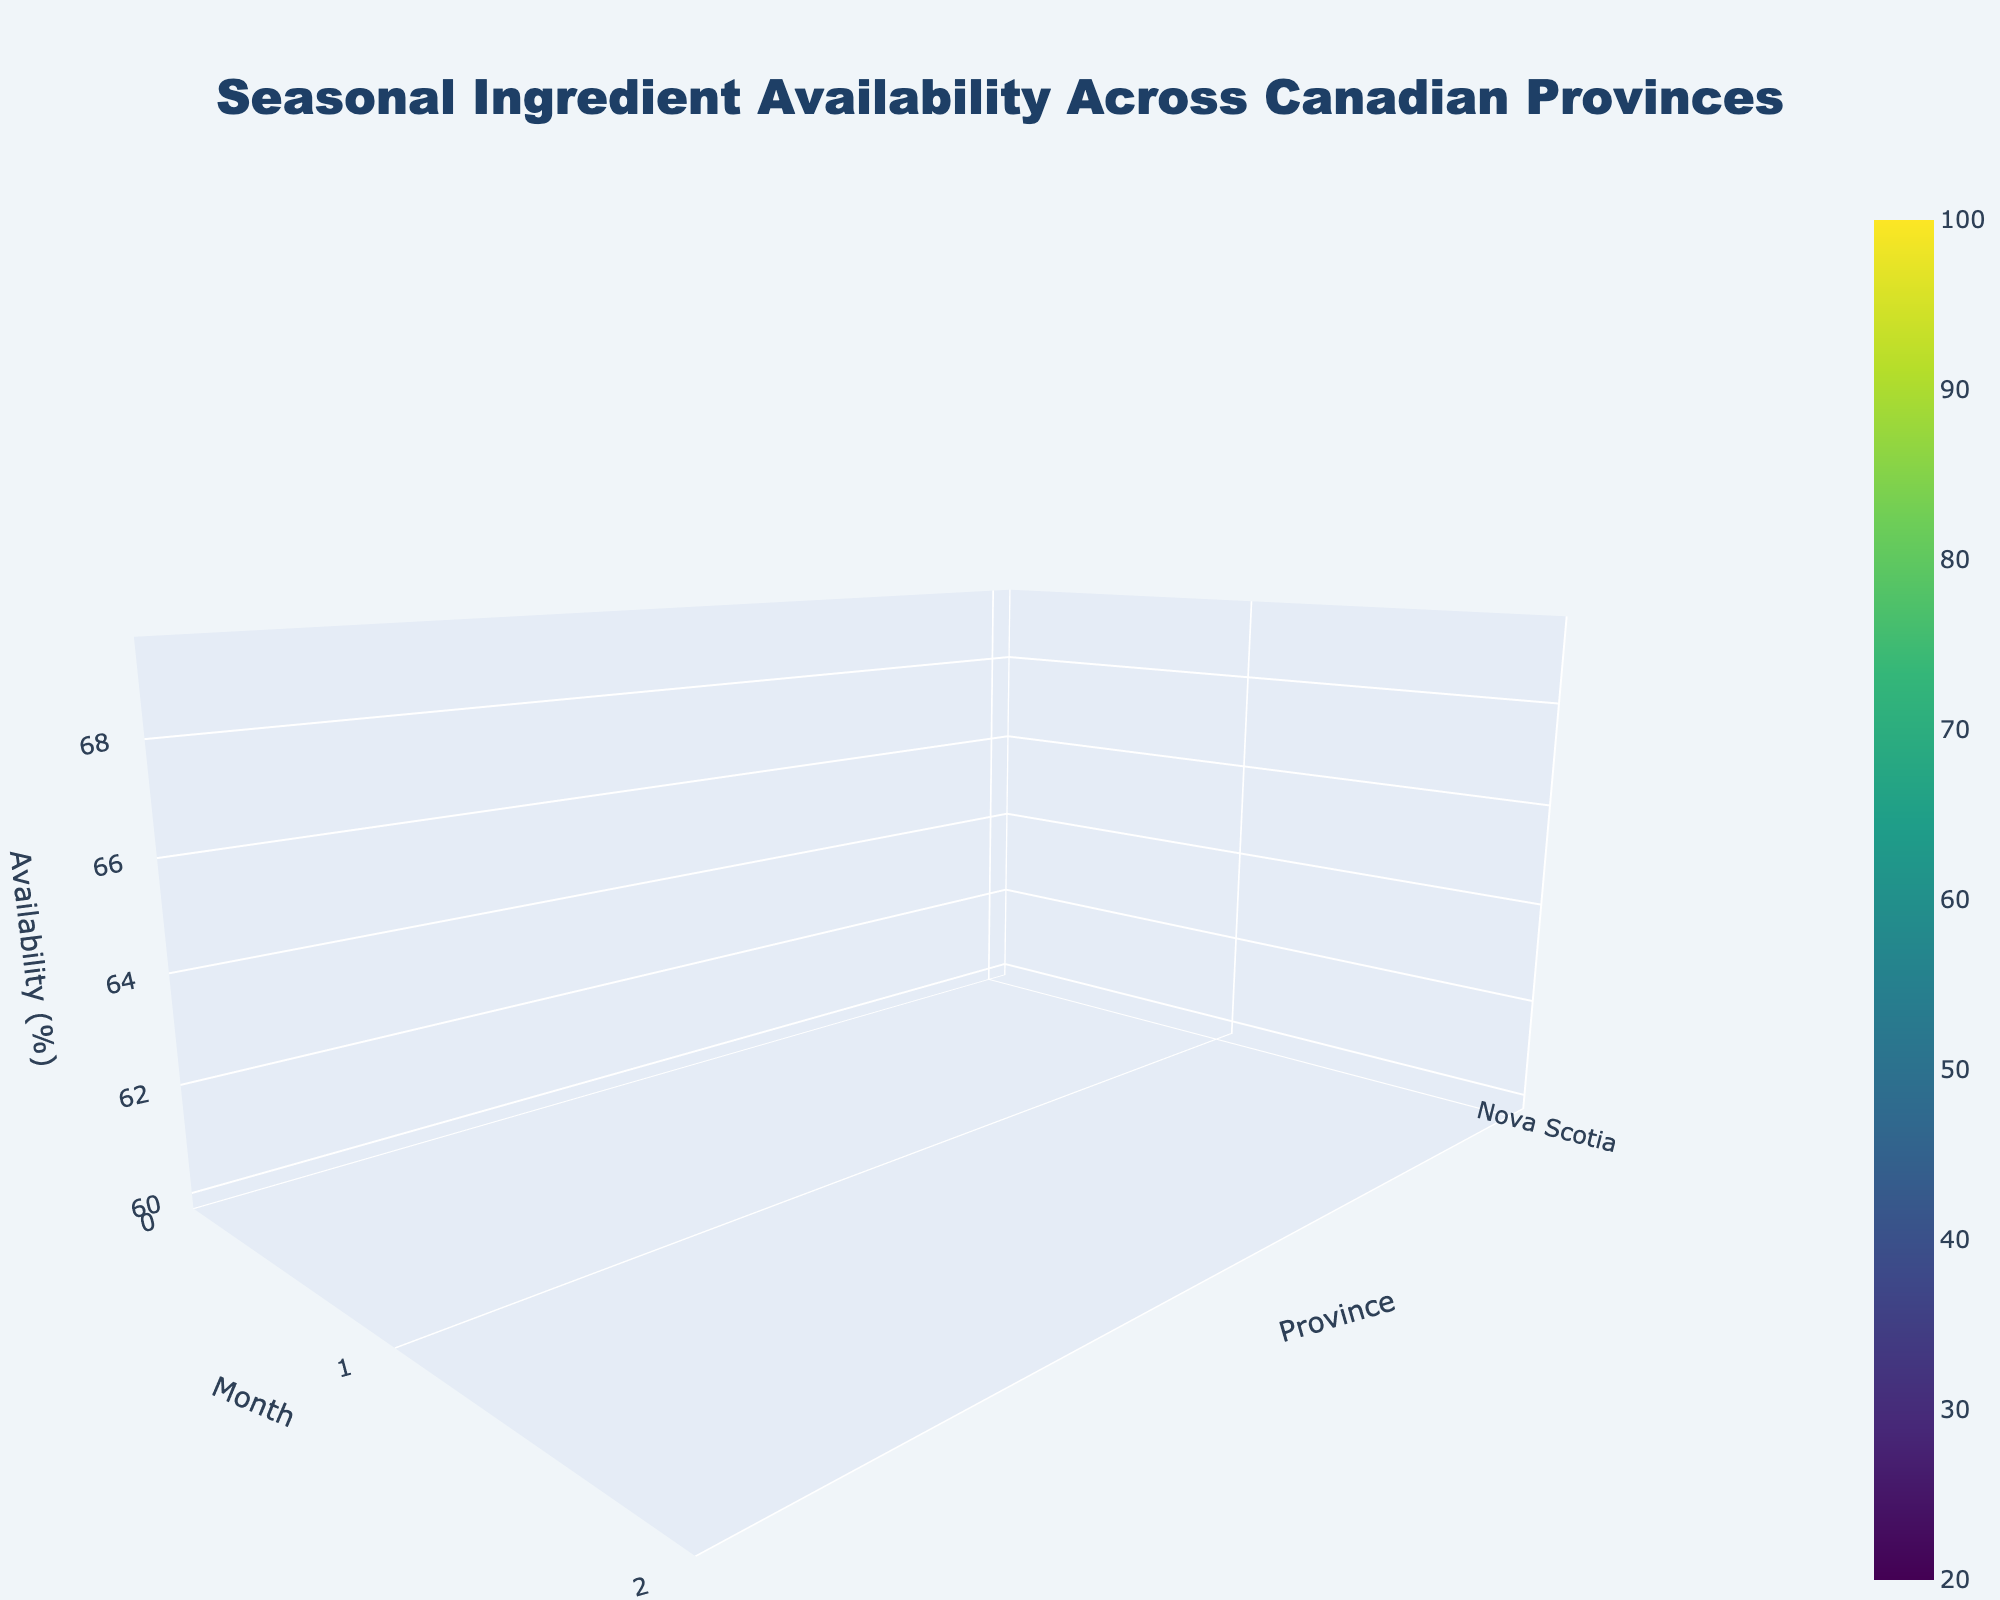What is the title of the figure? The title is typically located at the top of the plot. In this case, it reads "Seasonal Ingredient Availability Across Canadian Provinces".
Answer: Seasonal Ingredient Availability Across Canadian Provinces Which month has the highest availability overall? Observing the z-axis peaks across the 3D surface plot, the highest availability seems to be during months with high peaks like June and August. Comparing these months, August shows the highest availability.
Answer: August In which province is Maple Syrup most available in January? By identifying the January data points and their corresponding peaks on the surface for Maple Syrup, Quebec shows the highest availability.
Answer: Quebec What are the availability values in Ontario during June and October? Look for the surface plot values corresponding to Ontario (which is indexed on the y-axis) and match these with the June and October months on the x-axis. Values are 95% in June and 80% in October.
Answer: 95%, 80% Which province shows a significant peak in availability in February? By scanning for peaks in February on the 3D surface plot and cross-referencing with the y-axis labels for provinces, Alberta stands out with a peak in availability for Beef.
Answer: Alberta What is the average ingredient availability in Quebec from January to December? To calculate the average, sum up the availability values for Quebec across all 12 months, and then divide by 12.
Answer: 74.17% (rounded to two decimal places) Which month has the lowest seasonal ingredient availability, and in which province? By inspecting the troughs on the 3D surface plot, we find the lowest availability occurs in February in New Brunswick for Fiddleheads.
Answer: February, New Brunswick Between Ontario and Nova Scotia, which has higher ingredient availability in June? Comparing the height of the surfaces for Ontario and Nova Scotia in June, Ontario has higher availability at 95% versus Nova Scotia's 85%.
Answer: Ontario In how many months does British Columbia have an availability over 80%? Look along the x-axis for British Columbia and count the number of months where the surface plot exceeds an 80% threshold. British Columbia has high availability in January, June, and August.
Answer: 3 months Is there any province with a steady increase in availability over consecutive months? A steady increase over the months is depicted by a continuously rising surface plot in one direction. Most provinces have fluctuating patterns, yet Nova Scotia shows a general upward trend from March to June.
Answer: Nova Scotia 